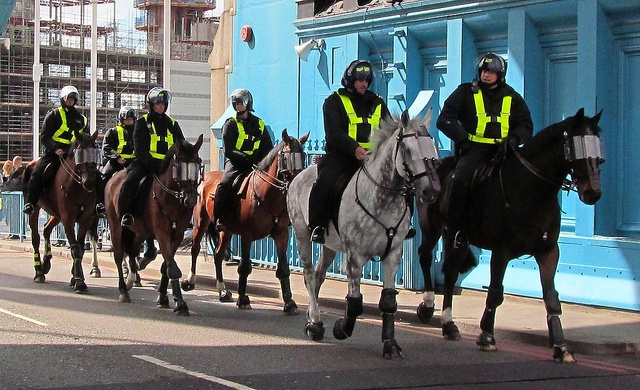Describe the objects in this image and their specific colors. I can see horse in teal, black, gray, and darkgray tones, horse in teal, gray, black, and darkgray tones, horse in teal, black, gray, brown, and maroon tones, people in teal, black, yellow, and gray tones, and horse in teal, black, maroon, gray, and darkgray tones in this image. 